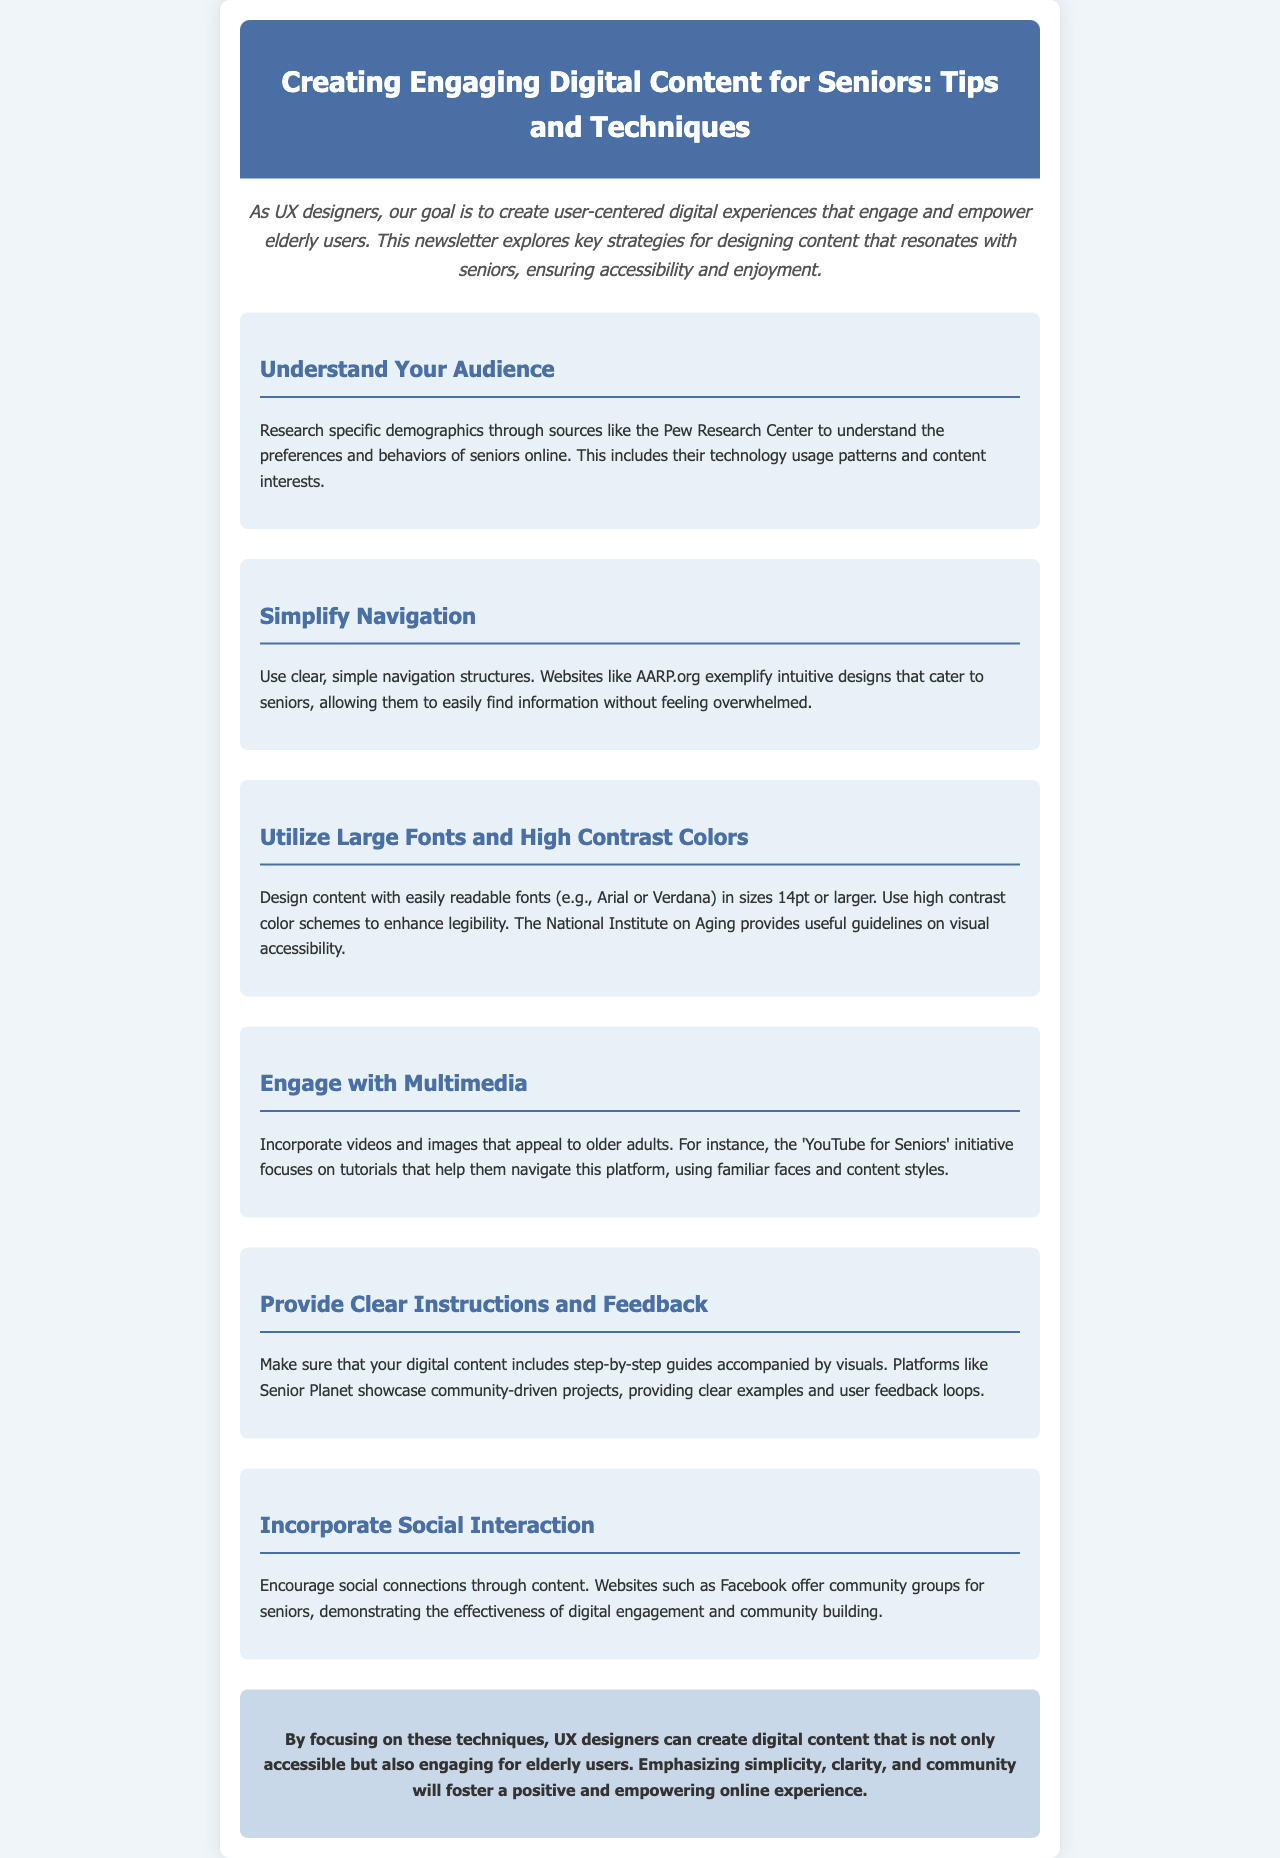what is the title of the newsletter? The title is found in the header section of the document.
Answer: Creating Engaging Digital Content for Seniors: Tips and Techniques who provides guidelines on visual accessibility? The guidelines for visual accessibility are mentioned in the section about large fonts and high contrast colors.
Answer: National Institute on Aging how much should fonts be sized for better readability? The specific font size recommendation is stated in the section about large fonts.
Answer: 14pt or larger which website is suggested for its intuitive design for seniors? The website referred to for its intuitive design is mentioned in the simplified navigation section.
Answer: AARP.org what main feature does 'YouTube for Seniors' initiative focus on? The main feature of the initiative is expressed in the multimedia engagement section of the document.
Answer: Tutorials what should be included with step-by-step guides for clarity? This information is found in the section about providing clear instructions.
Answer: Visuals which social media site is mentioned in relation to community building for seniors? This reference is made in the section about incorporating social interaction.
Answer: Facebook what is the primary goal of UX designers for elderly users as stated in the document? The primary goal is mentioned in the introduction of the newsletter.
Answer: User-centered digital experiences 